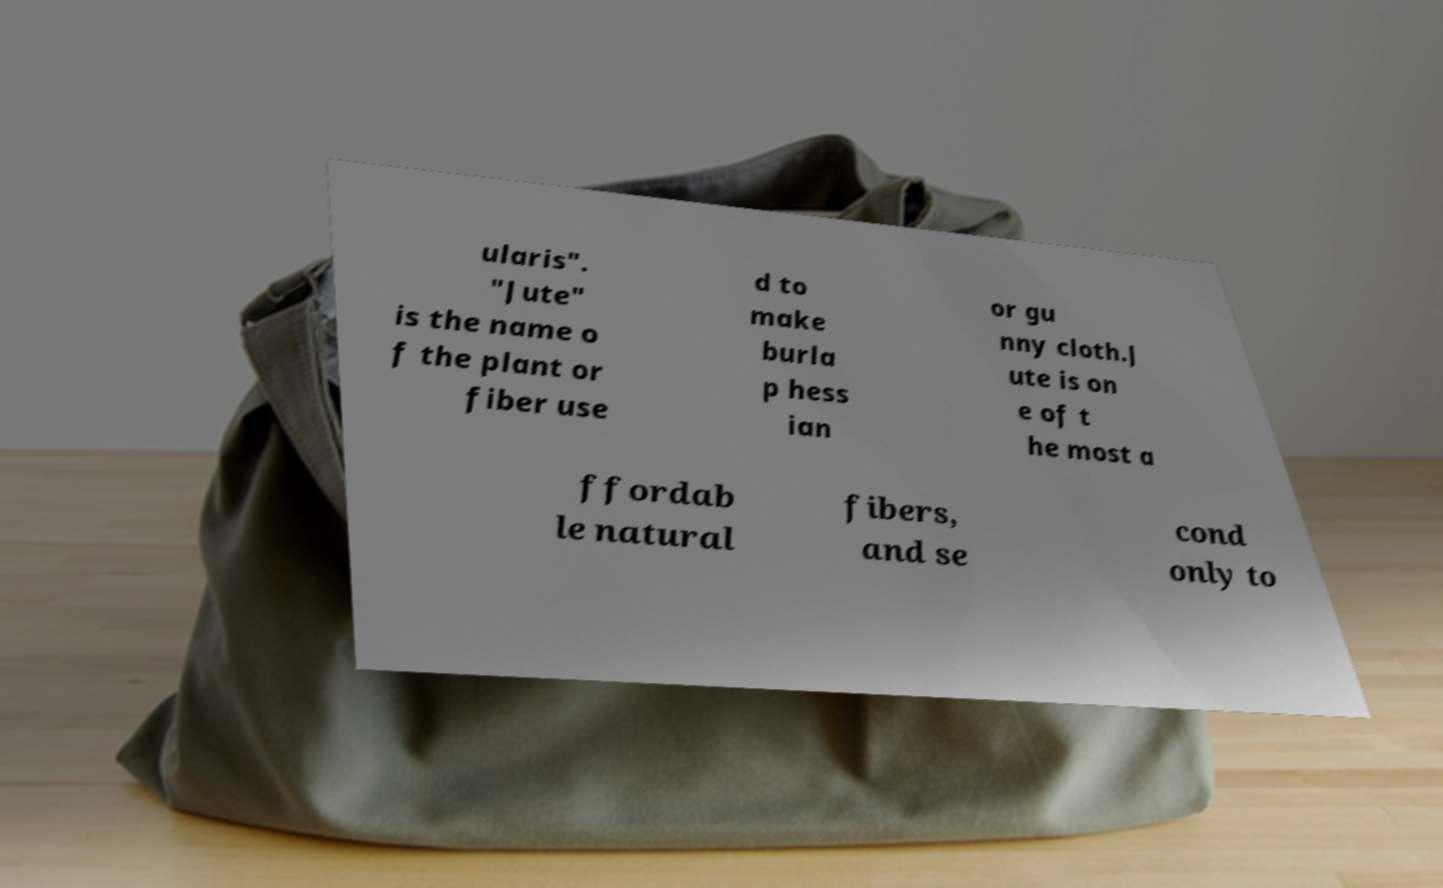Can you read and provide the text displayed in the image?This photo seems to have some interesting text. Can you extract and type it out for me? ularis". "Jute" is the name o f the plant or fiber use d to make burla p hess ian or gu nny cloth.J ute is on e of t he most a ffordab le natural fibers, and se cond only to 